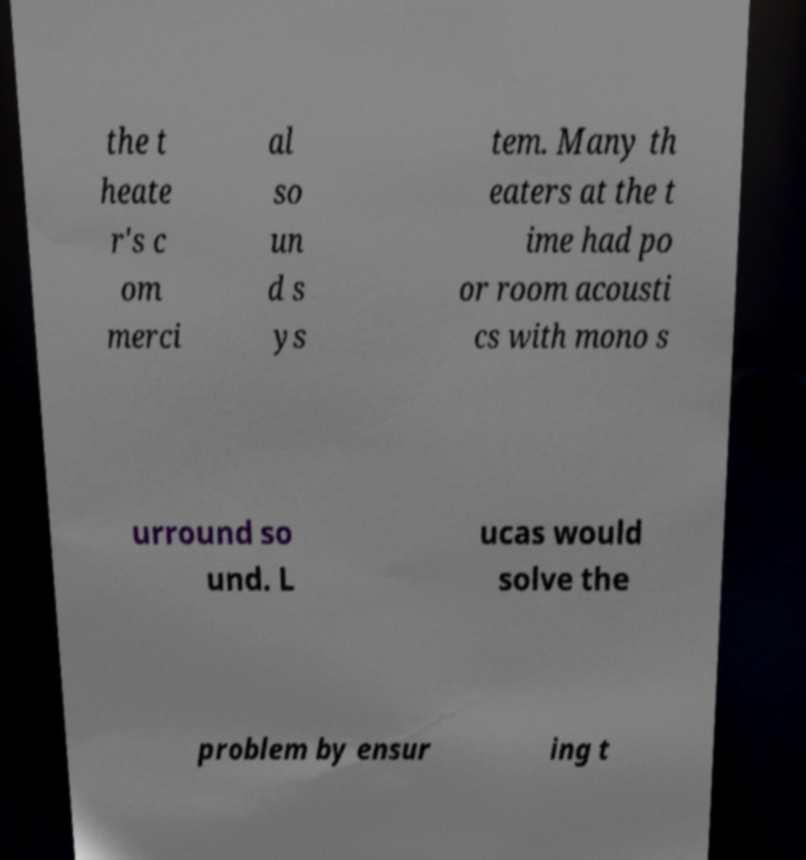I need the written content from this picture converted into text. Can you do that? the t heate r's c om merci al so un d s ys tem. Many th eaters at the t ime had po or room acousti cs with mono s urround so und. L ucas would solve the problem by ensur ing t 